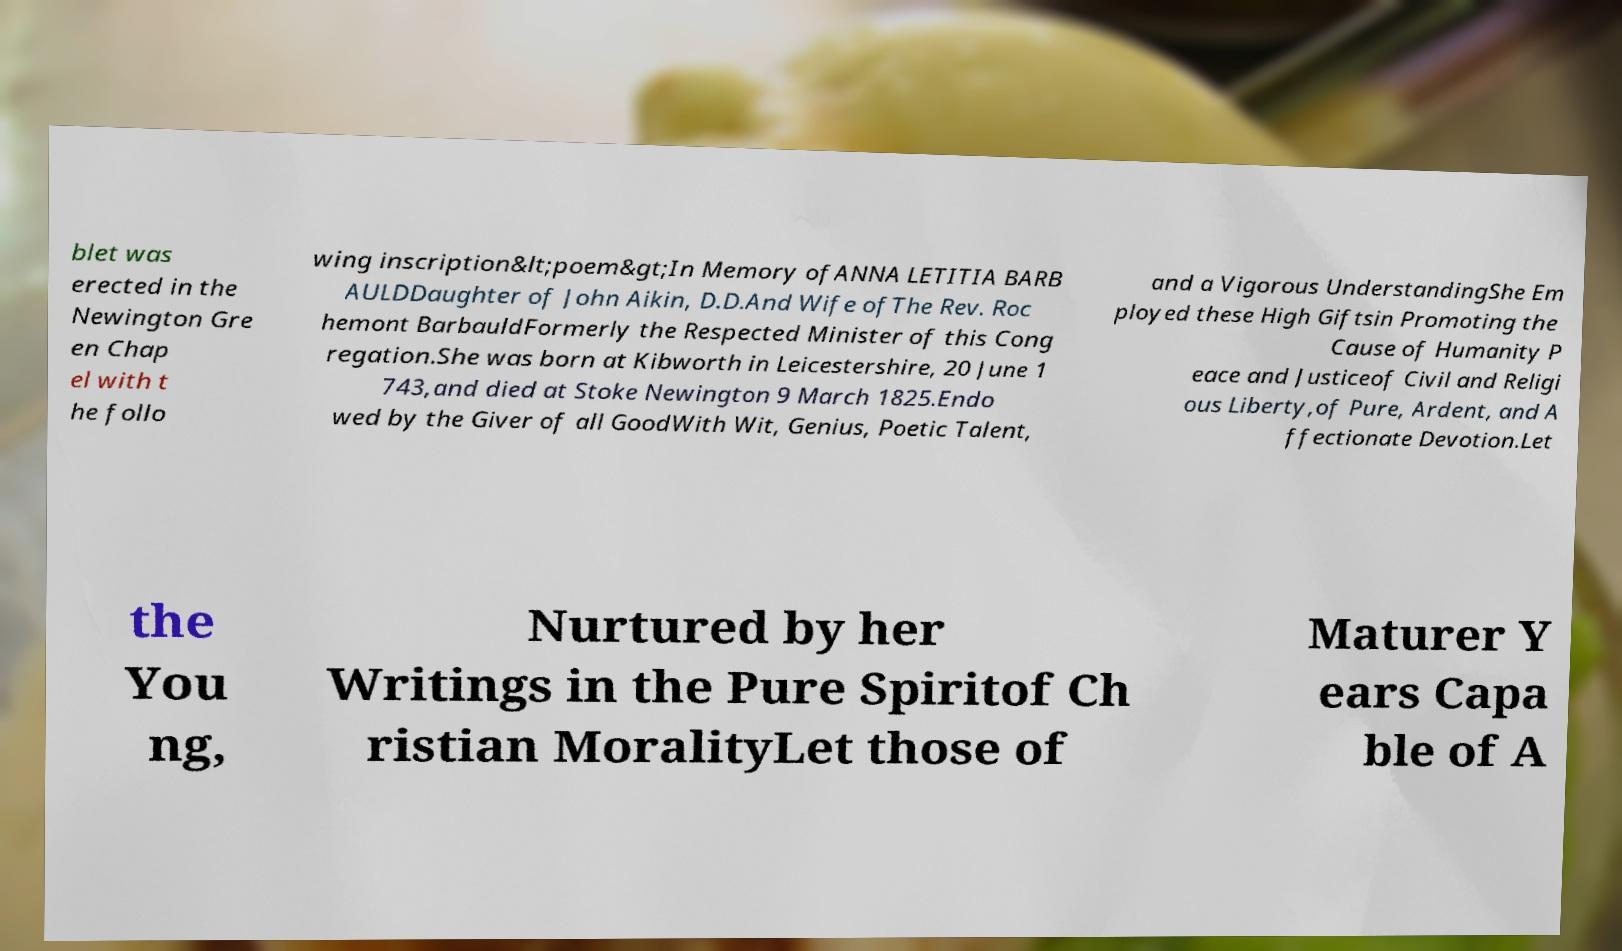There's text embedded in this image that I need extracted. Can you transcribe it verbatim? blet was erected in the Newington Gre en Chap el with t he follo wing inscription&lt;poem&gt;In Memory ofANNA LETITIA BARB AULDDaughter of John Aikin, D.D.And Wife ofThe Rev. Roc hemont BarbauldFormerly the Respected Minister of this Cong regation.She was born at Kibworth in Leicestershire, 20 June 1 743,and died at Stoke Newington 9 March 1825.Endo wed by the Giver of all GoodWith Wit, Genius, Poetic Talent, and a Vigorous UnderstandingShe Em ployed these High Giftsin Promoting the Cause of Humanity P eace and Justiceof Civil and Religi ous Liberty,of Pure, Ardent, and A ffectionate Devotion.Let the You ng, Nurtured by her Writings in the Pure Spiritof Ch ristian MoralityLet those of Maturer Y ears Capa ble of A 